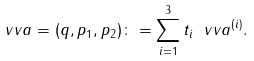Convert formula to latex. <formula><loc_0><loc_0><loc_500><loc_500>\ v v a = ( q , p _ { 1 } , p _ { 2 } ) \colon = \sum _ { i = 1 } ^ { 3 } t _ { i } \ v v a ^ { ( i ) } .</formula> 